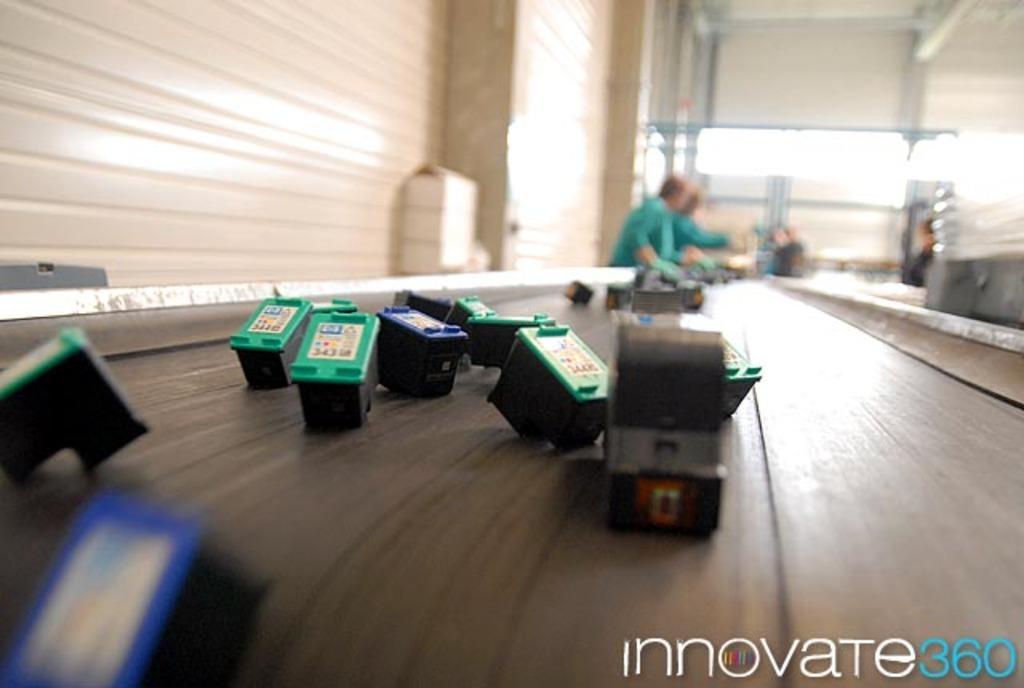Could you give a brief overview of what you see in this image? In the center of the image there is a table. On table we can see some objects are present. At the top of the image wall is there. In the middle of the image two persons are standing. 